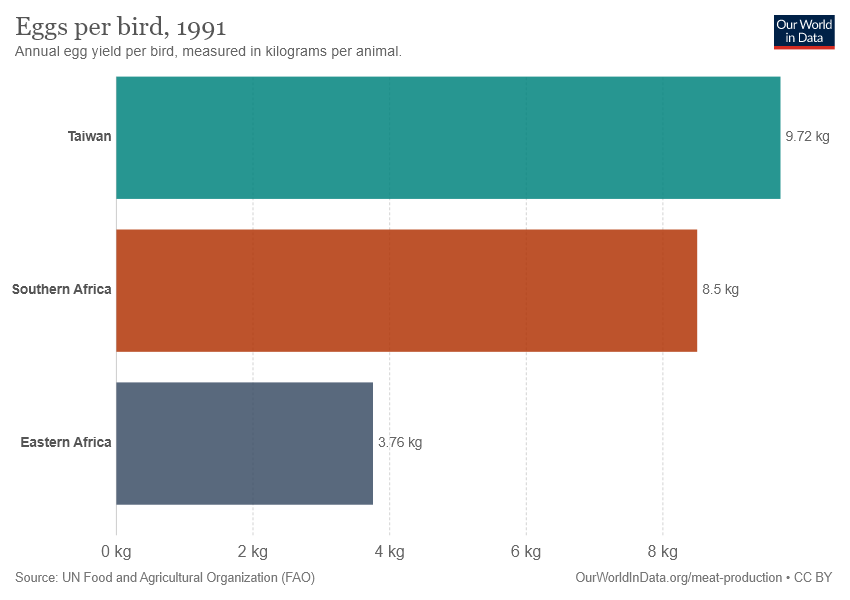Identify some key points in this picture. The difference between the largest two bars is 1.22. There are three bars in the graph. 